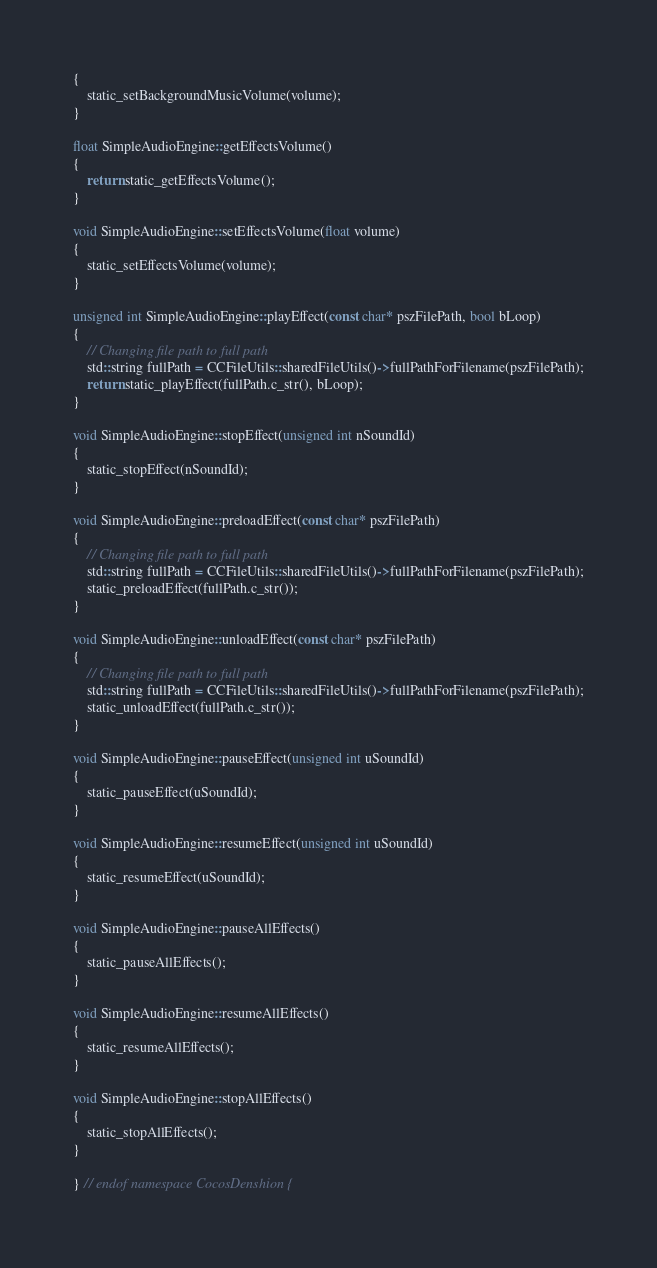<code> <loc_0><loc_0><loc_500><loc_500><_ObjectiveC_>{
    static_setBackgroundMusicVolume(volume);
}

float SimpleAudioEngine::getEffectsVolume()
{
    return static_getEffectsVolume();
}

void SimpleAudioEngine::setEffectsVolume(float volume)
{
    static_setEffectsVolume(volume);
}

unsigned int SimpleAudioEngine::playEffect(const char* pszFilePath, bool bLoop)
{
    // Changing file path to full path
    std::string fullPath = CCFileUtils::sharedFileUtils()->fullPathForFilename(pszFilePath);
    return static_playEffect(fullPath.c_str(), bLoop);
}

void SimpleAudioEngine::stopEffect(unsigned int nSoundId)
{
    static_stopEffect(nSoundId);
}

void SimpleAudioEngine::preloadEffect(const char* pszFilePath)
{
    // Changing file path to full path
    std::string fullPath = CCFileUtils::sharedFileUtils()->fullPathForFilename(pszFilePath);
    static_preloadEffect(fullPath.c_str());
}

void SimpleAudioEngine::unloadEffect(const char* pszFilePath)
{
    // Changing file path to full path
    std::string fullPath = CCFileUtils::sharedFileUtils()->fullPathForFilename(pszFilePath);
    static_unloadEffect(fullPath.c_str());
}

void SimpleAudioEngine::pauseEffect(unsigned int uSoundId)
{
    static_pauseEffect(uSoundId);
}

void SimpleAudioEngine::resumeEffect(unsigned int uSoundId)
{
    static_resumeEffect(uSoundId);
}

void SimpleAudioEngine::pauseAllEffects()
{
    static_pauseAllEffects();
}

void SimpleAudioEngine::resumeAllEffects()
{
    static_resumeAllEffects();
}

void SimpleAudioEngine::stopAllEffects()
{
    static_stopAllEffects();
}

} // endof namespace CocosDenshion {
</code> 